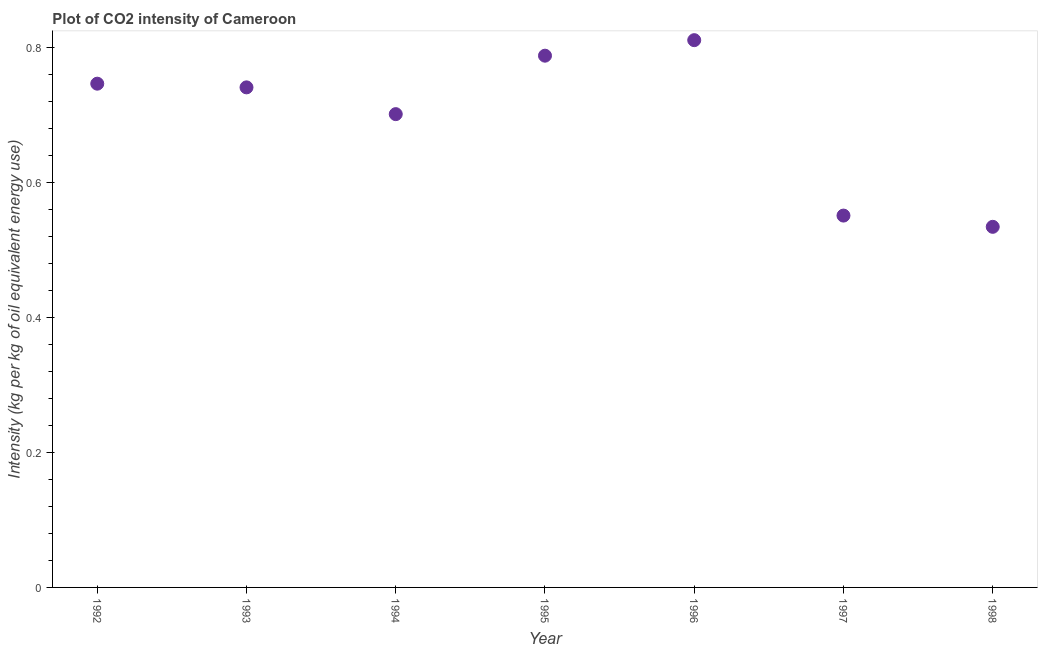What is the co2 intensity in 1994?
Make the answer very short. 0.7. Across all years, what is the maximum co2 intensity?
Give a very brief answer. 0.81. Across all years, what is the minimum co2 intensity?
Give a very brief answer. 0.53. In which year was the co2 intensity maximum?
Your response must be concise. 1996. In which year was the co2 intensity minimum?
Your answer should be compact. 1998. What is the sum of the co2 intensity?
Keep it short and to the point. 4.87. What is the difference between the co2 intensity in 1993 and 1995?
Make the answer very short. -0.05. What is the average co2 intensity per year?
Give a very brief answer. 0.7. What is the median co2 intensity?
Your response must be concise. 0.74. In how many years, is the co2 intensity greater than 0.4 kg?
Ensure brevity in your answer.  7. Do a majority of the years between 1994 and 1992 (inclusive) have co2 intensity greater than 0.04 kg?
Provide a short and direct response. No. What is the ratio of the co2 intensity in 1997 to that in 1998?
Offer a very short reply. 1.03. Is the co2 intensity in 1992 less than that in 1997?
Offer a very short reply. No. Is the difference between the co2 intensity in 1992 and 1998 greater than the difference between any two years?
Ensure brevity in your answer.  No. What is the difference between the highest and the second highest co2 intensity?
Your response must be concise. 0.02. What is the difference between the highest and the lowest co2 intensity?
Your answer should be very brief. 0.28. Does the co2 intensity monotonically increase over the years?
Ensure brevity in your answer.  No. How many dotlines are there?
Give a very brief answer. 1. How many years are there in the graph?
Offer a very short reply. 7. What is the difference between two consecutive major ticks on the Y-axis?
Your response must be concise. 0.2. Are the values on the major ticks of Y-axis written in scientific E-notation?
Your response must be concise. No. Does the graph contain grids?
Your response must be concise. No. What is the title of the graph?
Provide a short and direct response. Plot of CO2 intensity of Cameroon. What is the label or title of the Y-axis?
Your answer should be very brief. Intensity (kg per kg of oil equivalent energy use). What is the Intensity (kg per kg of oil equivalent energy use) in 1992?
Provide a short and direct response. 0.75. What is the Intensity (kg per kg of oil equivalent energy use) in 1993?
Your answer should be very brief. 0.74. What is the Intensity (kg per kg of oil equivalent energy use) in 1994?
Offer a terse response. 0.7. What is the Intensity (kg per kg of oil equivalent energy use) in 1995?
Keep it short and to the point. 0.79. What is the Intensity (kg per kg of oil equivalent energy use) in 1996?
Ensure brevity in your answer.  0.81. What is the Intensity (kg per kg of oil equivalent energy use) in 1997?
Provide a succinct answer. 0.55. What is the Intensity (kg per kg of oil equivalent energy use) in 1998?
Your response must be concise. 0.53. What is the difference between the Intensity (kg per kg of oil equivalent energy use) in 1992 and 1993?
Your response must be concise. 0.01. What is the difference between the Intensity (kg per kg of oil equivalent energy use) in 1992 and 1994?
Offer a terse response. 0.05. What is the difference between the Intensity (kg per kg of oil equivalent energy use) in 1992 and 1995?
Your answer should be compact. -0.04. What is the difference between the Intensity (kg per kg of oil equivalent energy use) in 1992 and 1996?
Provide a succinct answer. -0.06. What is the difference between the Intensity (kg per kg of oil equivalent energy use) in 1992 and 1997?
Give a very brief answer. 0.2. What is the difference between the Intensity (kg per kg of oil equivalent energy use) in 1992 and 1998?
Give a very brief answer. 0.21. What is the difference between the Intensity (kg per kg of oil equivalent energy use) in 1993 and 1994?
Make the answer very short. 0.04. What is the difference between the Intensity (kg per kg of oil equivalent energy use) in 1993 and 1995?
Your answer should be very brief. -0.05. What is the difference between the Intensity (kg per kg of oil equivalent energy use) in 1993 and 1996?
Provide a succinct answer. -0.07. What is the difference between the Intensity (kg per kg of oil equivalent energy use) in 1993 and 1997?
Your response must be concise. 0.19. What is the difference between the Intensity (kg per kg of oil equivalent energy use) in 1993 and 1998?
Your answer should be compact. 0.21. What is the difference between the Intensity (kg per kg of oil equivalent energy use) in 1994 and 1995?
Your answer should be very brief. -0.09. What is the difference between the Intensity (kg per kg of oil equivalent energy use) in 1994 and 1996?
Give a very brief answer. -0.11. What is the difference between the Intensity (kg per kg of oil equivalent energy use) in 1994 and 1997?
Offer a very short reply. 0.15. What is the difference between the Intensity (kg per kg of oil equivalent energy use) in 1994 and 1998?
Make the answer very short. 0.17. What is the difference between the Intensity (kg per kg of oil equivalent energy use) in 1995 and 1996?
Offer a very short reply. -0.02. What is the difference between the Intensity (kg per kg of oil equivalent energy use) in 1995 and 1997?
Provide a short and direct response. 0.24. What is the difference between the Intensity (kg per kg of oil equivalent energy use) in 1995 and 1998?
Make the answer very short. 0.25. What is the difference between the Intensity (kg per kg of oil equivalent energy use) in 1996 and 1997?
Offer a terse response. 0.26. What is the difference between the Intensity (kg per kg of oil equivalent energy use) in 1996 and 1998?
Make the answer very short. 0.28. What is the difference between the Intensity (kg per kg of oil equivalent energy use) in 1997 and 1998?
Your answer should be compact. 0.02. What is the ratio of the Intensity (kg per kg of oil equivalent energy use) in 1992 to that in 1994?
Your answer should be compact. 1.06. What is the ratio of the Intensity (kg per kg of oil equivalent energy use) in 1992 to that in 1995?
Provide a succinct answer. 0.95. What is the ratio of the Intensity (kg per kg of oil equivalent energy use) in 1992 to that in 1997?
Provide a succinct answer. 1.35. What is the ratio of the Intensity (kg per kg of oil equivalent energy use) in 1992 to that in 1998?
Provide a short and direct response. 1.4. What is the ratio of the Intensity (kg per kg of oil equivalent energy use) in 1993 to that in 1994?
Make the answer very short. 1.06. What is the ratio of the Intensity (kg per kg of oil equivalent energy use) in 1993 to that in 1996?
Ensure brevity in your answer.  0.91. What is the ratio of the Intensity (kg per kg of oil equivalent energy use) in 1993 to that in 1997?
Provide a short and direct response. 1.34. What is the ratio of the Intensity (kg per kg of oil equivalent energy use) in 1993 to that in 1998?
Provide a short and direct response. 1.39. What is the ratio of the Intensity (kg per kg of oil equivalent energy use) in 1994 to that in 1995?
Offer a very short reply. 0.89. What is the ratio of the Intensity (kg per kg of oil equivalent energy use) in 1994 to that in 1996?
Offer a terse response. 0.86. What is the ratio of the Intensity (kg per kg of oil equivalent energy use) in 1994 to that in 1997?
Make the answer very short. 1.27. What is the ratio of the Intensity (kg per kg of oil equivalent energy use) in 1994 to that in 1998?
Your answer should be compact. 1.31. What is the ratio of the Intensity (kg per kg of oil equivalent energy use) in 1995 to that in 1997?
Your answer should be very brief. 1.43. What is the ratio of the Intensity (kg per kg of oil equivalent energy use) in 1995 to that in 1998?
Give a very brief answer. 1.48. What is the ratio of the Intensity (kg per kg of oil equivalent energy use) in 1996 to that in 1997?
Offer a very short reply. 1.47. What is the ratio of the Intensity (kg per kg of oil equivalent energy use) in 1996 to that in 1998?
Your answer should be very brief. 1.52. What is the ratio of the Intensity (kg per kg of oil equivalent energy use) in 1997 to that in 1998?
Provide a succinct answer. 1.03. 